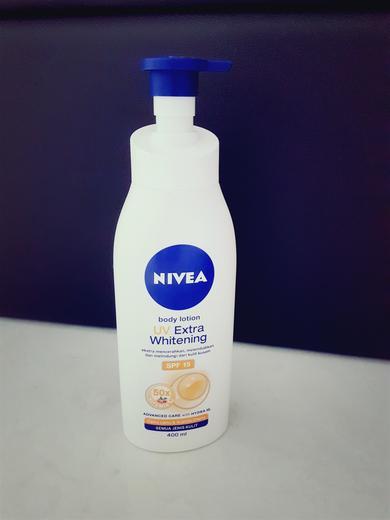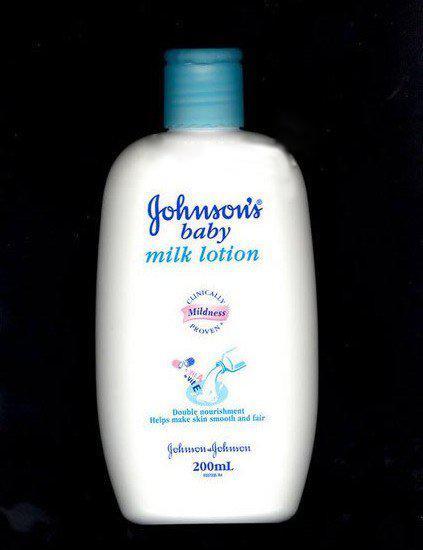The first image is the image on the left, the second image is the image on the right. For the images displayed, is the sentence "The left image contains at least two ointment containers." factually correct? Answer yes or no. No. 